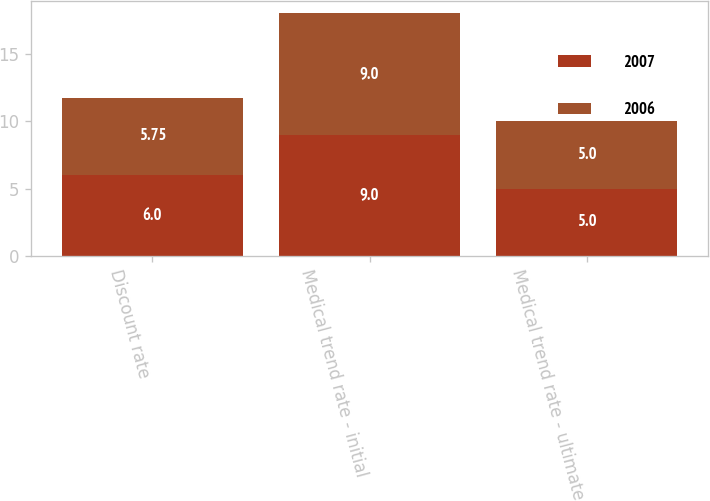Convert chart. <chart><loc_0><loc_0><loc_500><loc_500><stacked_bar_chart><ecel><fcel>Discount rate<fcel>Medical trend rate - initial<fcel>Medical trend rate - ultimate<nl><fcel>2007<fcel>6<fcel>9<fcel>5<nl><fcel>2006<fcel>5.75<fcel>9<fcel>5<nl></chart> 